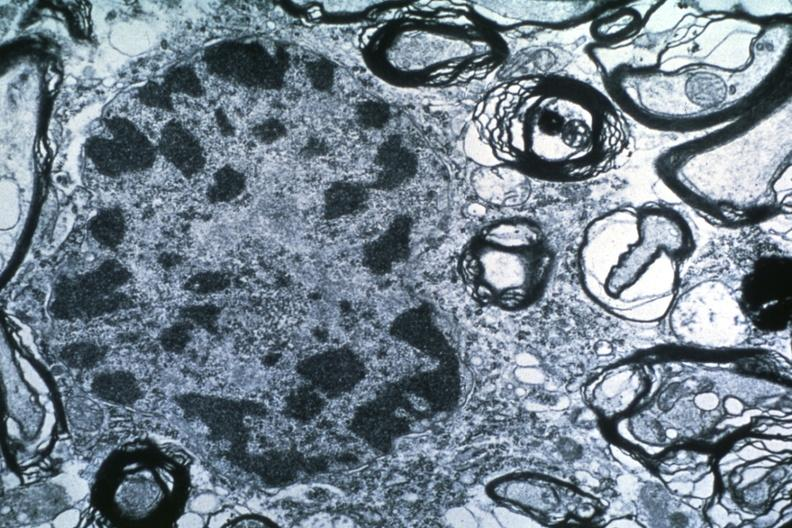what is present?
Answer the question using a single word or phrase. Brain 